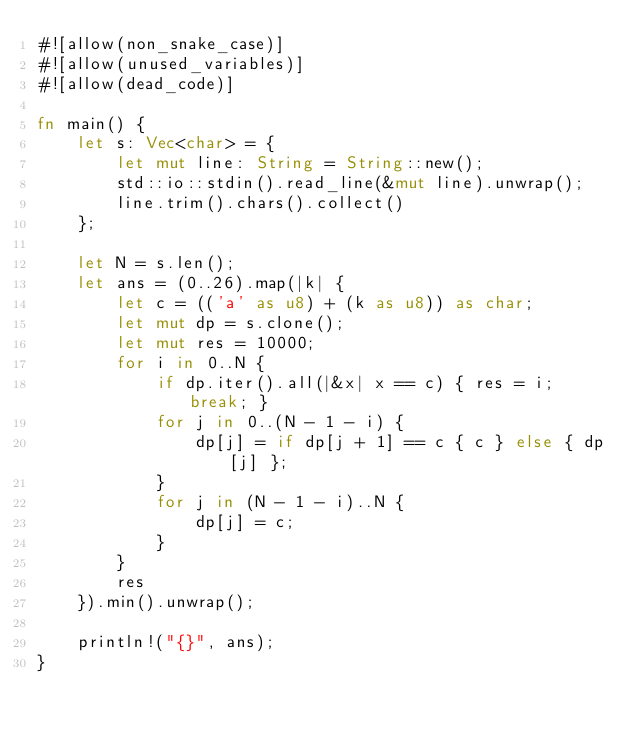Convert code to text. <code><loc_0><loc_0><loc_500><loc_500><_Rust_>#![allow(non_snake_case)]
#![allow(unused_variables)]
#![allow(dead_code)]

fn main() {
    let s: Vec<char> = {
        let mut line: String = String::new();
        std::io::stdin().read_line(&mut line).unwrap();
        line.trim().chars().collect()
    };

    let N = s.len();
    let ans = (0..26).map(|k| {
        let c = (('a' as u8) + (k as u8)) as char;
        let mut dp = s.clone();
        let mut res = 10000;
        for i in 0..N {
            if dp.iter().all(|&x| x == c) { res = i; break; }
            for j in 0..(N - 1 - i) {
                dp[j] = if dp[j + 1] == c { c } else { dp[j] };
            }
            for j in (N - 1 - i)..N {
                dp[j] = c;
            }
        }
        res
    }).min().unwrap();

    println!("{}", ans);
}</code> 